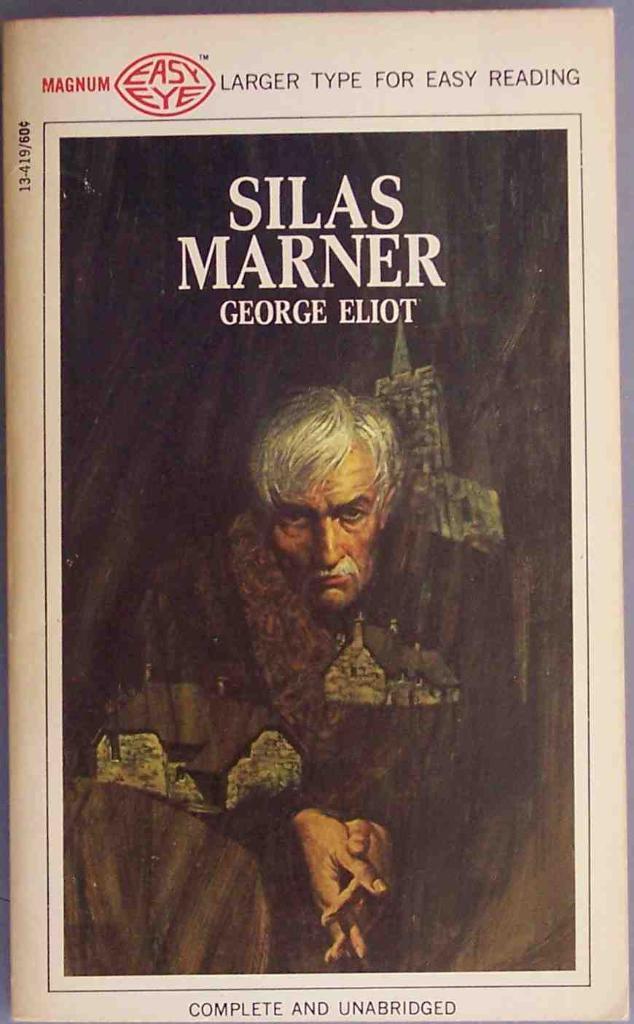Why kind of type is this book?
Ensure brevity in your answer.  Larger. Who is the author of this  book?
Make the answer very short. George eliot. 